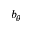<formula> <loc_0><loc_0><loc_500><loc_500>b _ { \theta }</formula> 